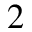<formula> <loc_0><loc_0><loc_500><loc_500>^ { 2 }</formula> 